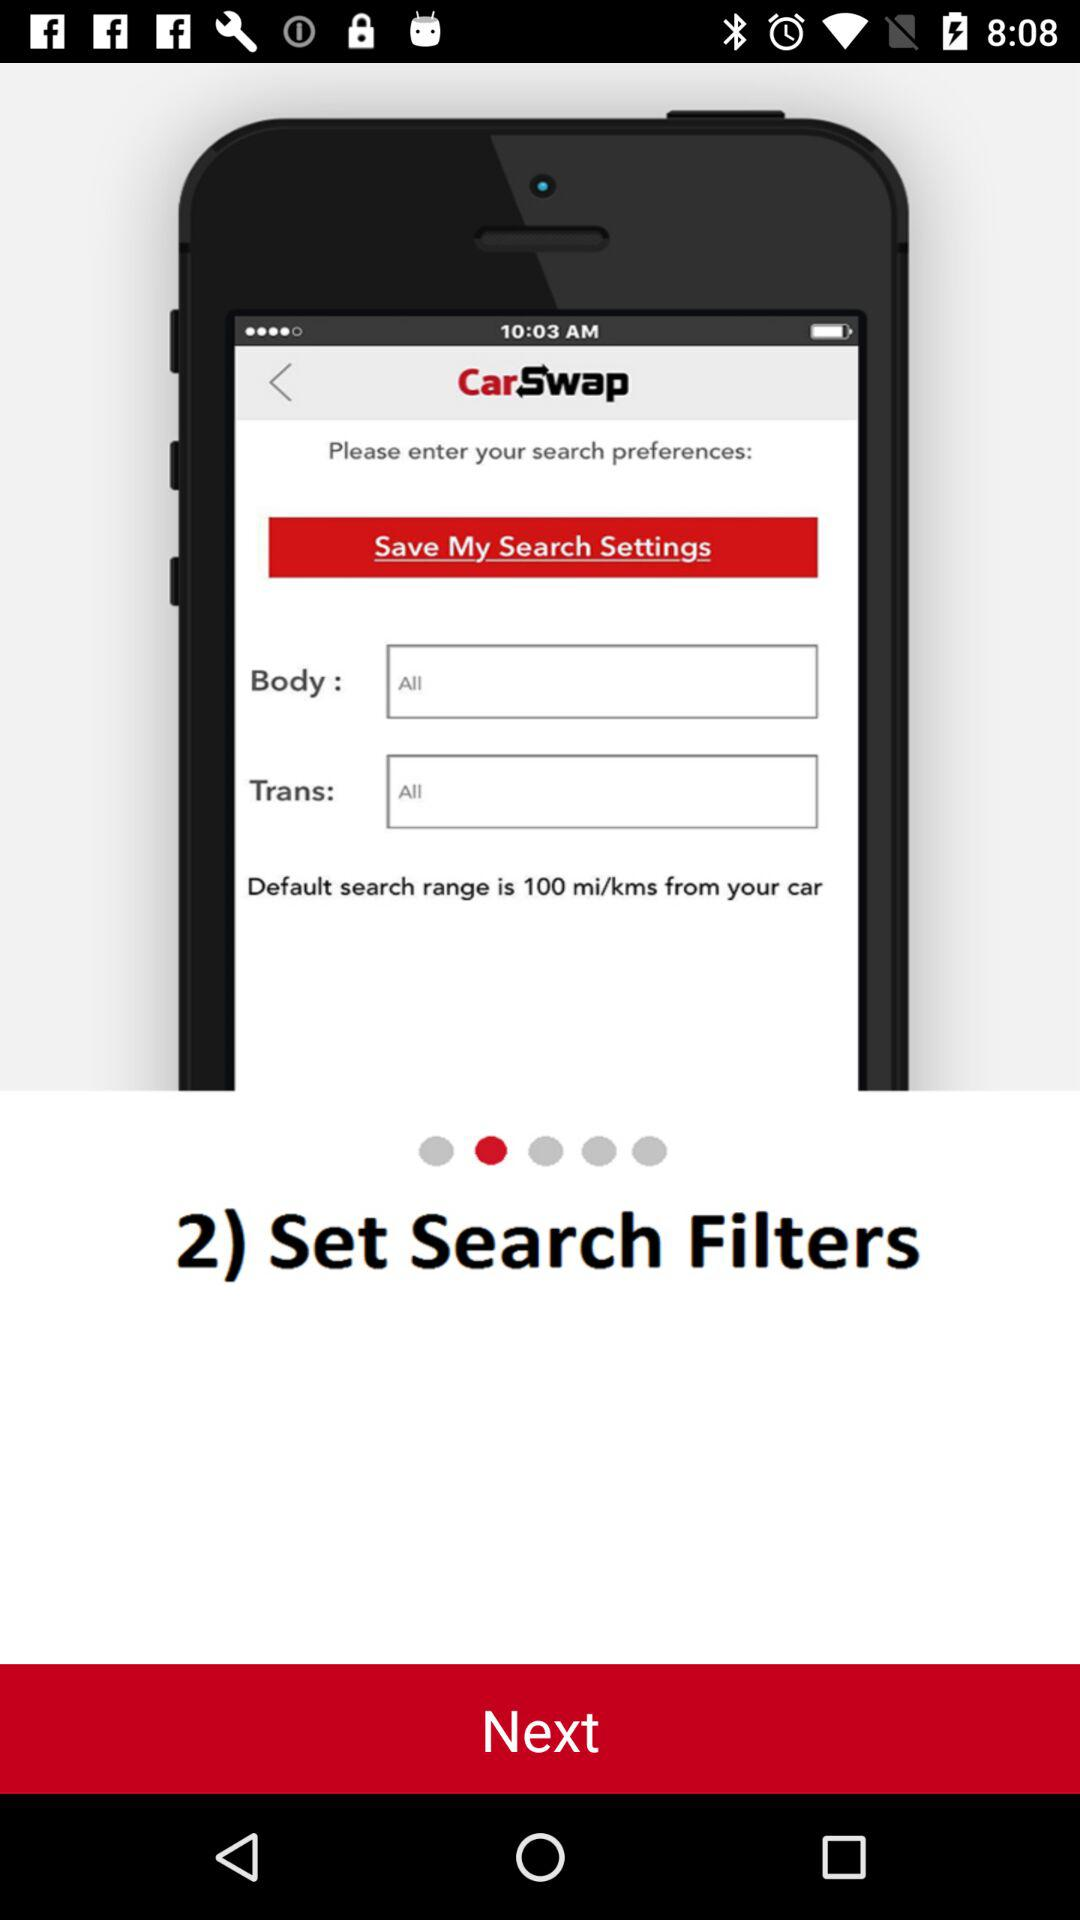What is the application name? The application name is "CarSwap". 